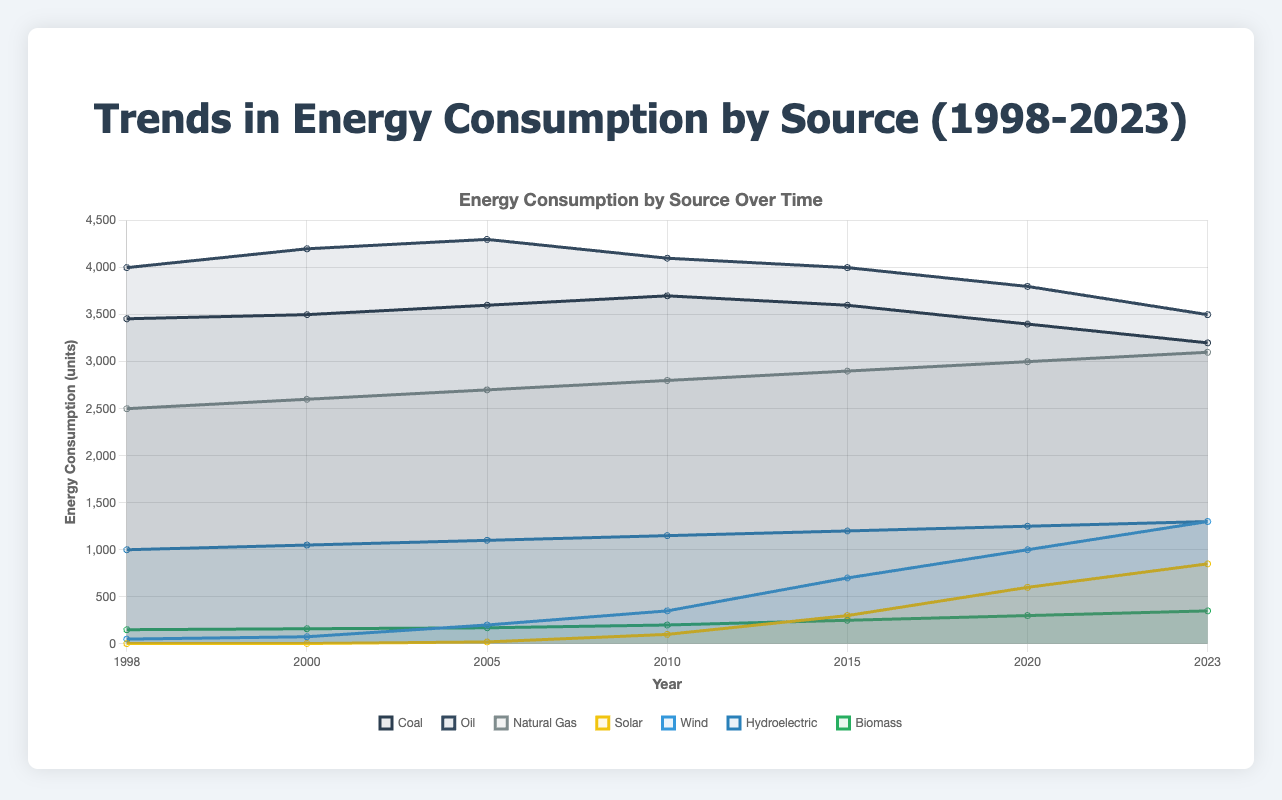What is the overall trend in coal consumption from 1998 to 2023? The coal consumption was 3456 units in 1998, slightly increased to 3700 units in 2010, and then steadily decreased to 3200 units in 2023. Thus, the overall trend shows a slight increase initially but a general decline towards the end.
Answer: General decline Which year experienced the most significant increase in solar energy consumption, and by how much did it increase compared to the previous data point? The year that experienced the most significant increase in solar energy was 2010, with an increase of 80 units compared to 2005 (100 - 20).
Answer: 2010, 80 units In 2023, which renewable energy source had the lowest consumption, and what was its value? In 2023, biomass had the lowest consumption among the renewable energy sources, with a value of 350 units.
Answer: Biomass, 350 units What is the percentage increase in wind energy consumption from 1998 to 2023? The wind energy consumption in 1998 was 50 units and in 2023 was 1300 units. The percentage increase is calculated as ((1300 - 50) / 50) * 100 = 2500%.
Answer: 2500% When did oil consumption peak, and what was the peak value? Oil consumption peaked in 2005 with a value of 4300 units.
Answer: 2005, 4300 units Between 1998 and 2023, which energy source showed the largest absolute increase in consumption? Solar energy showed the largest absolute increase, from 2 units in 1998 to 850 units in 2023, which is an increase of 848 units.
Answer: Solar, 848 units Which year had the highest total consumption of fossil fuels combined (coal, oil, and natural gas), and what was the total value? The year with the highest total consumption of fossil fuels was 2005, with a combined total of 10600 units (coal 3600 + oil 4300 + natural gas 2700).
Answer: 2005, 10600 units Comparing solar and wind energy in 2023, which one saw a larger absolute increase since 1998, and by how much? Solar energy increased from 2 units in 1998 to 850 units in 2023, an increase of 848 units. Wind energy increased from 50 units in 1998 to 1300 units in 2023, an increase of 1250 units. Therefore, wind saw a larger absolute increase of 402 units (1250 - 848).
Answer: Wind, 402 units How did hydroelectric energy consumption change from 1998 to 2023? Hydroelectric energy consumption increased steadily from 1000 units in 1998 to 1300 units in 2023. This is an increase of 300 units over 25 years.
Answer: Increased by 300 units What was the trend in biomass energy consumption over the years, and in what year did it reach 300 units? Biomass energy consumption steadily increased from 150 units in 1998 to 300 units in 2020.
Answer: Steadily increased, 2020 